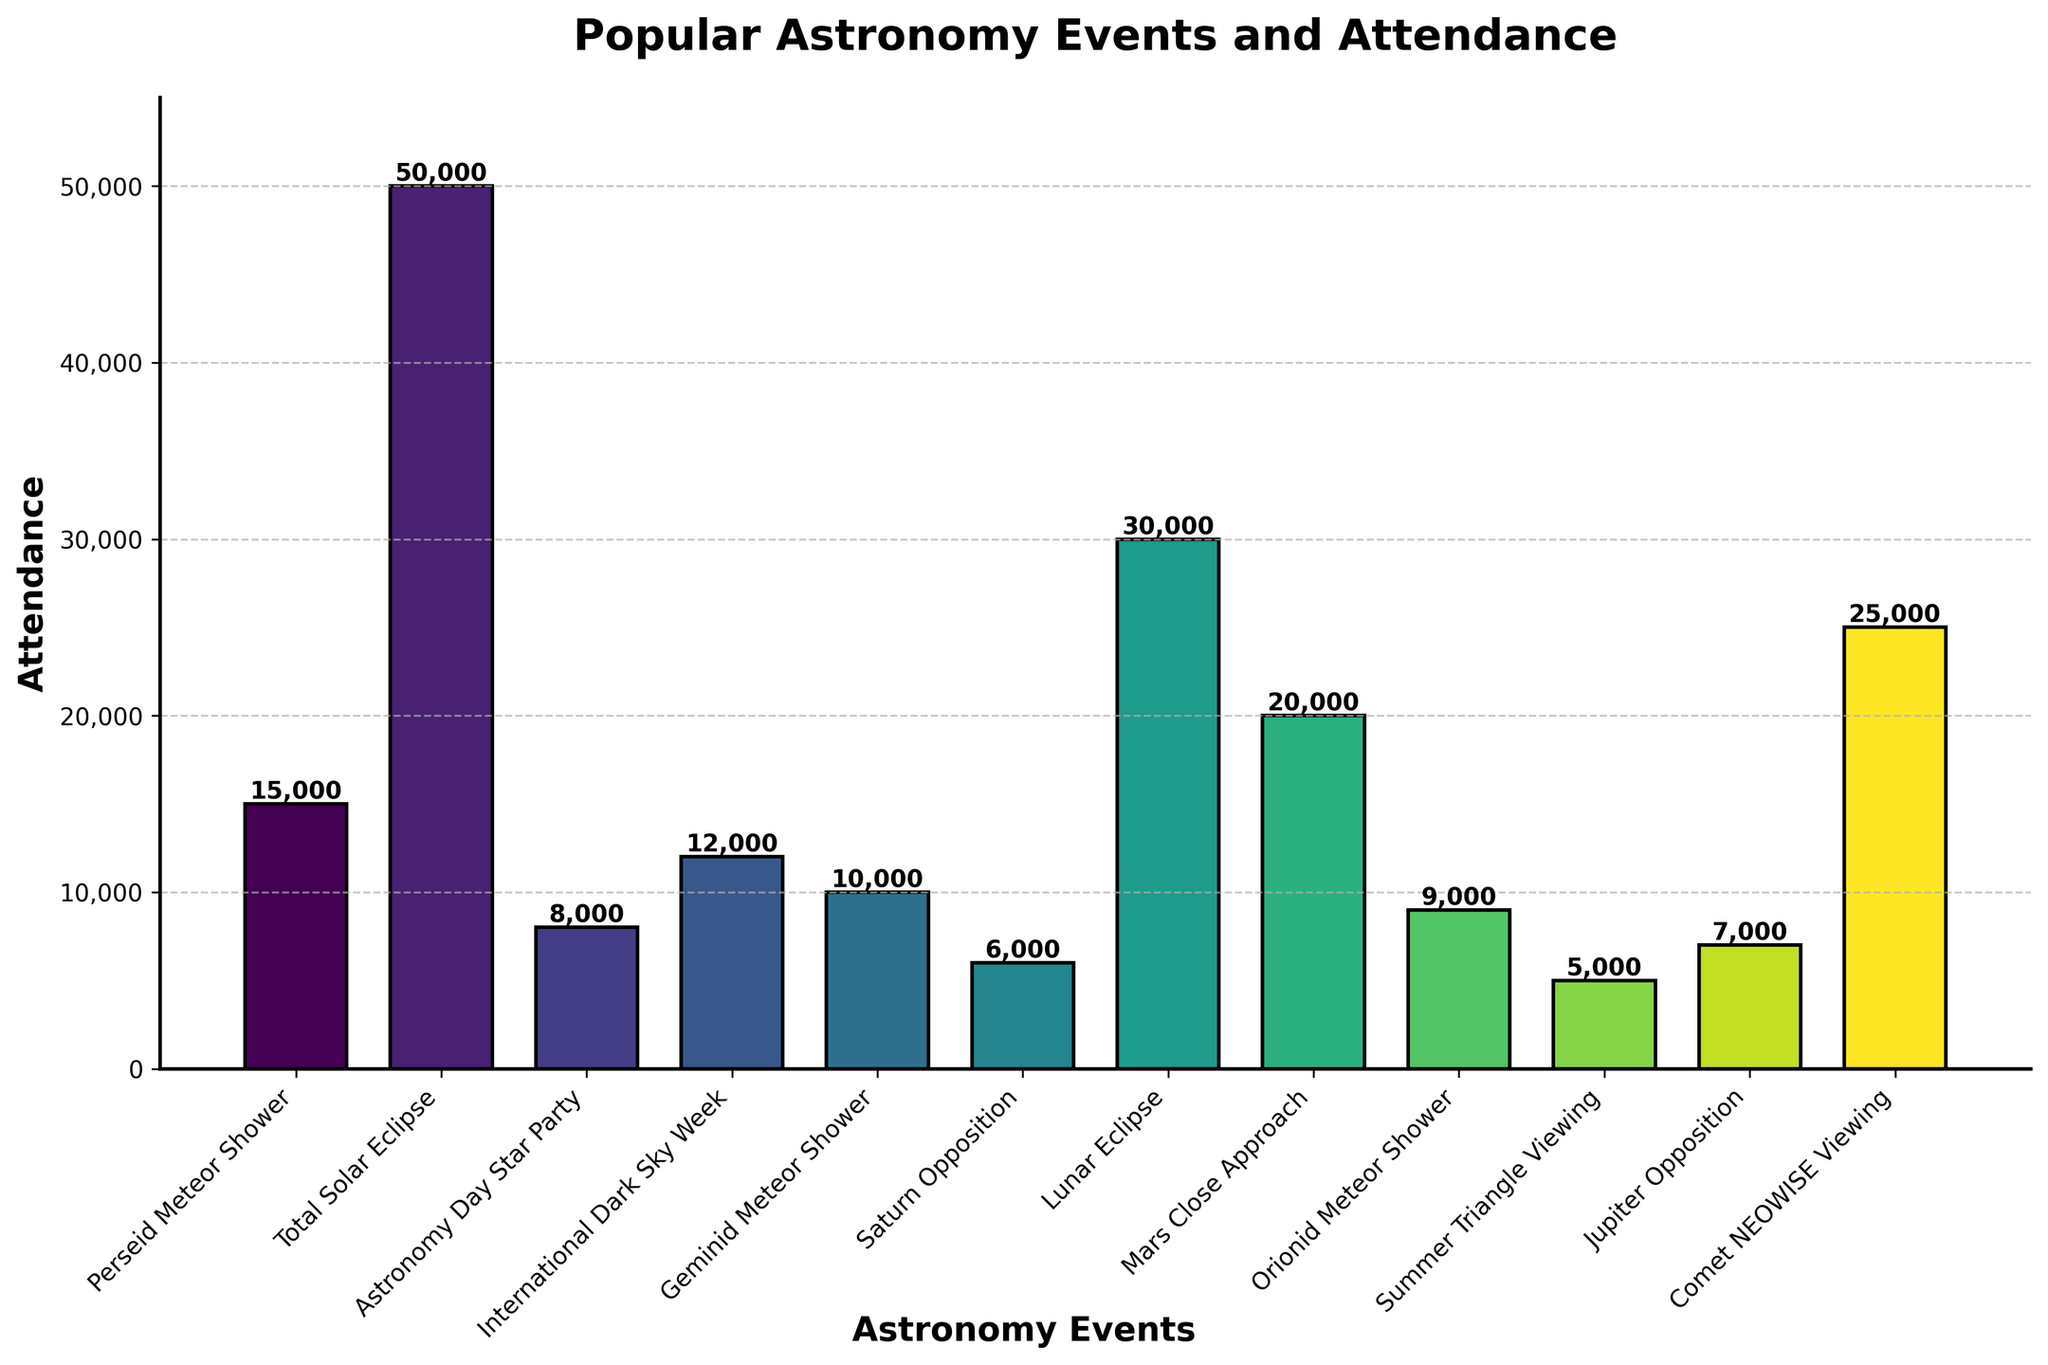Which event has the highest attendance? The event with the highest attendance is the Total Solar Eclipse bar, which is the tallest bar in the chart.
Answer: Total Solar Eclipse What is the difference in attendance between Comet NEOWISE Viewing and Summer Triangle Viewing? From the chart, Comet NEOWISE Viewing has an attendance of 25,000 and Summer Triangle Viewing has an attendance of 5,000. The difference is 25,000 - 5,000.
Answer: 20,000 Which two events have attendance rates closest to each other? Observing the heights of the bars, the attendance rates closest to each other are for the Orionid Meteor Shower (9,000) and Astronomy Day Star Party (8,000). The difference is minimal.
Answer: Orionid Meteor Shower and Astronomy Day Star Party What is the total attendance for all meteor shower events mentioned in the chart? The meteor shower events are: Perseid Meteor Shower (15,000), Geminid Meteor Shower (10,000), and Orionid Meteor Shower (9,000). Adding them together gives 15,000 + 10,000 + 9,000.
Answer: 34,000 Which event has the color of the bar closest to green? By looking at the color gradients in the chart, the bar for Perseid Meteor Shower is closest to green.
Answer: Perseid Meteor Shower How much higher is the attendance of the Lunar Eclipse compared to the Mars Close Approach? The attendance for Lunar Eclipse is 30,000 and for Mars Close Approach, it's 20,000. The difference can be calculated as 30,000 - 20,000.
Answer: 10,000 Which event has the lowest attendance and what is it? The event with the lowest attendance is the Summer Triangle Viewing, with an attendance rate of 5,000.
Answer: Summer Triangle Viewing 